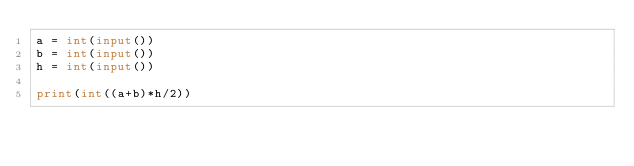Convert code to text. <code><loc_0><loc_0><loc_500><loc_500><_Python_>a = int(input())
b = int(input())
h = int(input())

print(int((a+b)*h/2))</code> 